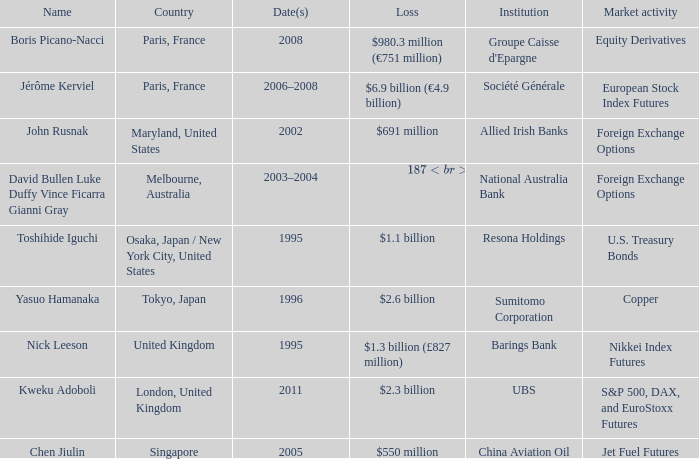What was the loss for Boris Picano-Nacci? $980.3 million (€751 million). 